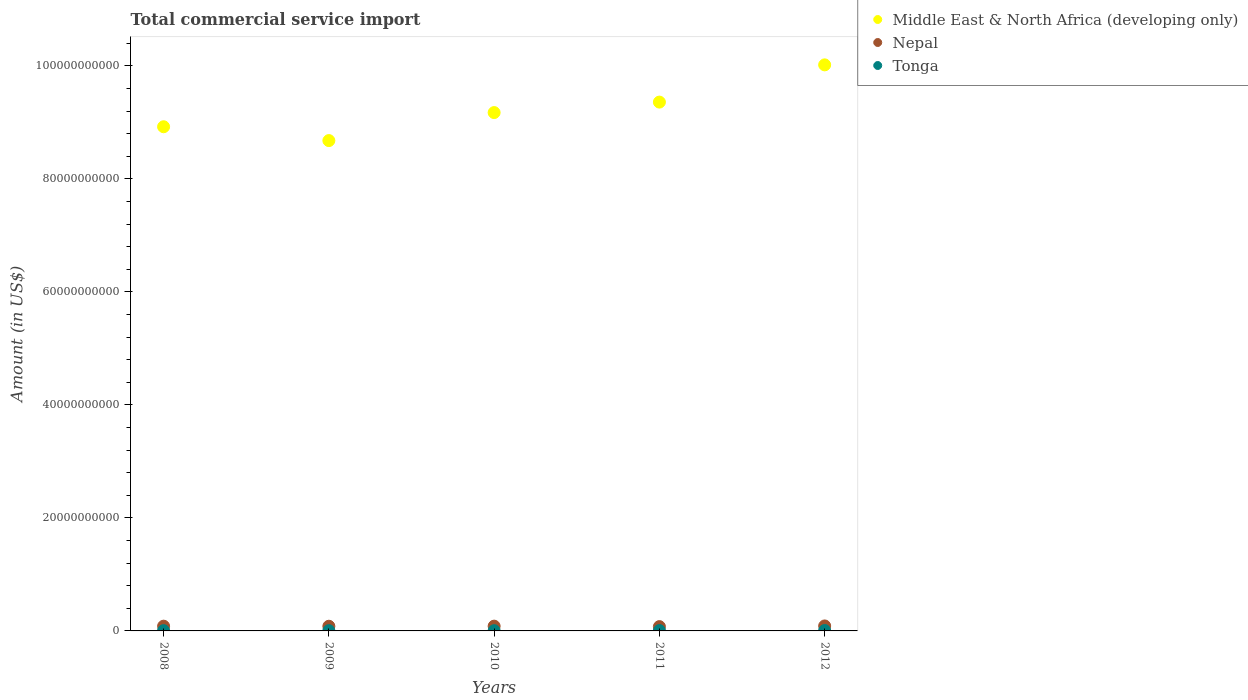How many different coloured dotlines are there?
Offer a very short reply. 3. What is the total commercial service import in Middle East & North Africa (developing only) in 2012?
Your answer should be compact. 1.00e+11. Across all years, what is the maximum total commercial service import in Middle East & North Africa (developing only)?
Ensure brevity in your answer.  1.00e+11. Across all years, what is the minimum total commercial service import in Middle East & North Africa (developing only)?
Offer a very short reply. 8.68e+1. In which year was the total commercial service import in Nepal minimum?
Make the answer very short. 2011. What is the total total commercial service import in Tonga in the graph?
Your answer should be very brief. 2.72e+08. What is the difference between the total commercial service import in Middle East & North Africa (developing only) in 2008 and that in 2009?
Offer a terse response. 2.45e+09. What is the difference between the total commercial service import in Tonga in 2012 and the total commercial service import in Nepal in 2010?
Ensure brevity in your answer.  -7.72e+08. What is the average total commercial service import in Middle East & North Africa (developing only) per year?
Provide a short and direct response. 9.23e+1. In the year 2008, what is the difference between the total commercial service import in Middle East & North Africa (developing only) and total commercial service import in Tonga?
Offer a terse response. 8.92e+1. In how many years, is the total commercial service import in Tonga greater than 88000000000 US$?
Ensure brevity in your answer.  0. What is the ratio of the total commercial service import in Tonga in 2009 to that in 2011?
Provide a succinct answer. 0.7. Is the total commercial service import in Nepal in 2008 less than that in 2009?
Offer a very short reply. No. Is the difference between the total commercial service import in Middle East & North Africa (developing only) in 2008 and 2011 greater than the difference between the total commercial service import in Tonga in 2008 and 2011?
Ensure brevity in your answer.  No. What is the difference between the highest and the second highest total commercial service import in Middle East & North Africa (developing only)?
Make the answer very short. 6.59e+09. What is the difference between the highest and the lowest total commercial service import in Middle East & North Africa (developing only)?
Your answer should be compact. 1.34e+1. In how many years, is the total commercial service import in Middle East & North Africa (developing only) greater than the average total commercial service import in Middle East & North Africa (developing only) taken over all years?
Offer a terse response. 2. Is the sum of the total commercial service import in Nepal in 2008 and 2009 greater than the maximum total commercial service import in Tonga across all years?
Your response must be concise. Yes. Does the total commercial service import in Middle East & North Africa (developing only) monotonically increase over the years?
Provide a succinct answer. No. Is the total commercial service import in Tonga strictly greater than the total commercial service import in Middle East & North Africa (developing only) over the years?
Your answer should be compact. No. Is the total commercial service import in Nepal strictly less than the total commercial service import in Tonga over the years?
Offer a terse response. No. How many dotlines are there?
Your answer should be very brief. 3. What is the difference between two consecutive major ticks on the Y-axis?
Offer a terse response. 2.00e+1. Does the graph contain any zero values?
Your answer should be compact. No. How many legend labels are there?
Offer a very short reply. 3. What is the title of the graph?
Provide a succinct answer. Total commercial service import. What is the label or title of the Y-axis?
Ensure brevity in your answer.  Amount (in US$). What is the Amount (in US$) in Middle East & North Africa (developing only) in 2008?
Your answer should be compact. 8.92e+1. What is the Amount (in US$) of Nepal in 2008?
Ensure brevity in your answer.  8.40e+08. What is the Amount (in US$) in Tonga in 2008?
Your answer should be very brief. 4.82e+07. What is the Amount (in US$) in Middle East & North Africa (developing only) in 2009?
Your answer should be very brief. 8.68e+1. What is the Amount (in US$) of Nepal in 2009?
Ensure brevity in your answer.  8.28e+08. What is the Amount (in US$) in Tonga in 2009?
Your answer should be very brief. 4.43e+07. What is the Amount (in US$) in Middle East & North Africa (developing only) in 2010?
Provide a short and direct response. 9.17e+1. What is the Amount (in US$) in Nepal in 2010?
Offer a very short reply. 8.45e+08. What is the Amount (in US$) of Tonga in 2010?
Provide a succinct answer. 4.24e+07. What is the Amount (in US$) of Middle East & North Africa (developing only) in 2011?
Make the answer very short. 9.36e+1. What is the Amount (in US$) in Nepal in 2011?
Ensure brevity in your answer.  7.61e+08. What is the Amount (in US$) in Tonga in 2011?
Ensure brevity in your answer.  6.34e+07. What is the Amount (in US$) of Middle East & North Africa (developing only) in 2012?
Give a very brief answer. 1.00e+11. What is the Amount (in US$) of Nepal in 2012?
Ensure brevity in your answer.  8.82e+08. What is the Amount (in US$) of Tonga in 2012?
Provide a short and direct response. 7.36e+07. Across all years, what is the maximum Amount (in US$) of Middle East & North Africa (developing only)?
Your response must be concise. 1.00e+11. Across all years, what is the maximum Amount (in US$) in Nepal?
Make the answer very short. 8.82e+08. Across all years, what is the maximum Amount (in US$) of Tonga?
Offer a very short reply. 7.36e+07. Across all years, what is the minimum Amount (in US$) of Middle East & North Africa (developing only)?
Offer a terse response. 8.68e+1. Across all years, what is the minimum Amount (in US$) in Nepal?
Ensure brevity in your answer.  7.61e+08. Across all years, what is the minimum Amount (in US$) of Tonga?
Your response must be concise. 4.24e+07. What is the total Amount (in US$) of Middle East & North Africa (developing only) in the graph?
Your response must be concise. 4.62e+11. What is the total Amount (in US$) in Nepal in the graph?
Ensure brevity in your answer.  4.16e+09. What is the total Amount (in US$) in Tonga in the graph?
Your response must be concise. 2.72e+08. What is the difference between the Amount (in US$) in Middle East & North Africa (developing only) in 2008 and that in 2009?
Your answer should be very brief. 2.45e+09. What is the difference between the Amount (in US$) of Nepal in 2008 and that in 2009?
Your response must be concise. 1.26e+07. What is the difference between the Amount (in US$) in Tonga in 2008 and that in 2009?
Your response must be concise. 3.97e+06. What is the difference between the Amount (in US$) of Middle East & North Africa (developing only) in 2008 and that in 2010?
Make the answer very short. -2.51e+09. What is the difference between the Amount (in US$) in Nepal in 2008 and that in 2010?
Make the answer very short. -5.02e+06. What is the difference between the Amount (in US$) in Tonga in 2008 and that in 2010?
Offer a very short reply. 5.78e+06. What is the difference between the Amount (in US$) in Middle East & North Africa (developing only) in 2008 and that in 2011?
Keep it short and to the point. -4.36e+09. What is the difference between the Amount (in US$) of Nepal in 2008 and that in 2011?
Ensure brevity in your answer.  7.88e+07. What is the difference between the Amount (in US$) in Tonga in 2008 and that in 2011?
Your response must be concise. -1.52e+07. What is the difference between the Amount (in US$) in Middle East & North Africa (developing only) in 2008 and that in 2012?
Make the answer very short. -1.10e+1. What is the difference between the Amount (in US$) in Nepal in 2008 and that in 2012?
Provide a short and direct response. -4.16e+07. What is the difference between the Amount (in US$) in Tonga in 2008 and that in 2012?
Your response must be concise. -2.54e+07. What is the difference between the Amount (in US$) in Middle East & North Africa (developing only) in 2009 and that in 2010?
Give a very brief answer. -4.96e+09. What is the difference between the Amount (in US$) in Nepal in 2009 and that in 2010?
Provide a succinct answer. -1.76e+07. What is the difference between the Amount (in US$) in Tonga in 2009 and that in 2010?
Keep it short and to the point. 1.81e+06. What is the difference between the Amount (in US$) in Middle East & North Africa (developing only) in 2009 and that in 2011?
Your answer should be very brief. -6.81e+09. What is the difference between the Amount (in US$) in Nepal in 2009 and that in 2011?
Keep it short and to the point. 6.61e+07. What is the difference between the Amount (in US$) of Tonga in 2009 and that in 2011?
Provide a succinct answer. -1.92e+07. What is the difference between the Amount (in US$) of Middle East & North Africa (developing only) in 2009 and that in 2012?
Provide a short and direct response. -1.34e+1. What is the difference between the Amount (in US$) in Nepal in 2009 and that in 2012?
Make the answer very short. -5.43e+07. What is the difference between the Amount (in US$) of Tonga in 2009 and that in 2012?
Provide a short and direct response. -2.93e+07. What is the difference between the Amount (in US$) in Middle East & North Africa (developing only) in 2010 and that in 2011?
Provide a succinct answer. -1.85e+09. What is the difference between the Amount (in US$) in Nepal in 2010 and that in 2011?
Keep it short and to the point. 8.38e+07. What is the difference between the Amount (in US$) of Tonga in 2010 and that in 2011?
Provide a succinct answer. -2.10e+07. What is the difference between the Amount (in US$) in Middle East & North Africa (developing only) in 2010 and that in 2012?
Offer a terse response. -8.44e+09. What is the difference between the Amount (in US$) in Nepal in 2010 and that in 2012?
Provide a succinct answer. -3.66e+07. What is the difference between the Amount (in US$) of Tonga in 2010 and that in 2012?
Provide a succinct answer. -3.11e+07. What is the difference between the Amount (in US$) of Middle East & North Africa (developing only) in 2011 and that in 2012?
Make the answer very short. -6.59e+09. What is the difference between the Amount (in US$) in Nepal in 2011 and that in 2012?
Provide a short and direct response. -1.20e+08. What is the difference between the Amount (in US$) in Tonga in 2011 and that in 2012?
Make the answer very short. -1.02e+07. What is the difference between the Amount (in US$) of Middle East & North Africa (developing only) in 2008 and the Amount (in US$) of Nepal in 2009?
Offer a terse response. 8.84e+1. What is the difference between the Amount (in US$) of Middle East & North Africa (developing only) in 2008 and the Amount (in US$) of Tonga in 2009?
Offer a very short reply. 8.92e+1. What is the difference between the Amount (in US$) of Nepal in 2008 and the Amount (in US$) of Tonga in 2009?
Your answer should be compact. 7.96e+08. What is the difference between the Amount (in US$) of Middle East & North Africa (developing only) in 2008 and the Amount (in US$) of Nepal in 2010?
Keep it short and to the point. 8.84e+1. What is the difference between the Amount (in US$) of Middle East & North Africa (developing only) in 2008 and the Amount (in US$) of Tonga in 2010?
Ensure brevity in your answer.  8.92e+1. What is the difference between the Amount (in US$) of Nepal in 2008 and the Amount (in US$) of Tonga in 2010?
Your answer should be very brief. 7.98e+08. What is the difference between the Amount (in US$) of Middle East & North Africa (developing only) in 2008 and the Amount (in US$) of Nepal in 2011?
Give a very brief answer. 8.85e+1. What is the difference between the Amount (in US$) of Middle East & North Africa (developing only) in 2008 and the Amount (in US$) of Tonga in 2011?
Offer a terse response. 8.92e+1. What is the difference between the Amount (in US$) in Nepal in 2008 and the Amount (in US$) in Tonga in 2011?
Make the answer very short. 7.77e+08. What is the difference between the Amount (in US$) in Middle East & North Africa (developing only) in 2008 and the Amount (in US$) in Nepal in 2012?
Give a very brief answer. 8.83e+1. What is the difference between the Amount (in US$) in Middle East & North Africa (developing only) in 2008 and the Amount (in US$) in Tonga in 2012?
Provide a succinct answer. 8.92e+1. What is the difference between the Amount (in US$) in Nepal in 2008 and the Amount (in US$) in Tonga in 2012?
Offer a terse response. 7.67e+08. What is the difference between the Amount (in US$) in Middle East & North Africa (developing only) in 2009 and the Amount (in US$) in Nepal in 2010?
Your answer should be very brief. 8.59e+1. What is the difference between the Amount (in US$) in Middle East & North Africa (developing only) in 2009 and the Amount (in US$) in Tonga in 2010?
Your answer should be compact. 8.67e+1. What is the difference between the Amount (in US$) of Nepal in 2009 and the Amount (in US$) of Tonga in 2010?
Make the answer very short. 7.85e+08. What is the difference between the Amount (in US$) in Middle East & North Africa (developing only) in 2009 and the Amount (in US$) in Nepal in 2011?
Keep it short and to the point. 8.60e+1. What is the difference between the Amount (in US$) of Middle East & North Africa (developing only) in 2009 and the Amount (in US$) of Tonga in 2011?
Provide a short and direct response. 8.67e+1. What is the difference between the Amount (in US$) of Nepal in 2009 and the Amount (in US$) of Tonga in 2011?
Keep it short and to the point. 7.64e+08. What is the difference between the Amount (in US$) of Middle East & North Africa (developing only) in 2009 and the Amount (in US$) of Nepal in 2012?
Your answer should be very brief. 8.59e+1. What is the difference between the Amount (in US$) of Middle East & North Africa (developing only) in 2009 and the Amount (in US$) of Tonga in 2012?
Offer a terse response. 8.67e+1. What is the difference between the Amount (in US$) in Nepal in 2009 and the Amount (in US$) in Tonga in 2012?
Provide a succinct answer. 7.54e+08. What is the difference between the Amount (in US$) in Middle East & North Africa (developing only) in 2010 and the Amount (in US$) in Nepal in 2011?
Offer a terse response. 9.10e+1. What is the difference between the Amount (in US$) of Middle East & North Africa (developing only) in 2010 and the Amount (in US$) of Tonga in 2011?
Ensure brevity in your answer.  9.17e+1. What is the difference between the Amount (in US$) of Nepal in 2010 and the Amount (in US$) of Tonga in 2011?
Offer a very short reply. 7.82e+08. What is the difference between the Amount (in US$) in Middle East & North Africa (developing only) in 2010 and the Amount (in US$) in Nepal in 2012?
Provide a succinct answer. 9.09e+1. What is the difference between the Amount (in US$) of Middle East & North Africa (developing only) in 2010 and the Amount (in US$) of Tonga in 2012?
Your answer should be compact. 9.17e+1. What is the difference between the Amount (in US$) of Nepal in 2010 and the Amount (in US$) of Tonga in 2012?
Offer a terse response. 7.72e+08. What is the difference between the Amount (in US$) in Middle East & North Africa (developing only) in 2011 and the Amount (in US$) in Nepal in 2012?
Provide a short and direct response. 9.27e+1. What is the difference between the Amount (in US$) of Middle East & North Africa (developing only) in 2011 and the Amount (in US$) of Tonga in 2012?
Keep it short and to the point. 9.35e+1. What is the difference between the Amount (in US$) of Nepal in 2011 and the Amount (in US$) of Tonga in 2012?
Provide a short and direct response. 6.88e+08. What is the average Amount (in US$) of Middle East & North Africa (developing only) per year?
Make the answer very short. 9.23e+1. What is the average Amount (in US$) in Nepal per year?
Make the answer very short. 8.31e+08. What is the average Amount (in US$) of Tonga per year?
Your response must be concise. 5.44e+07. In the year 2008, what is the difference between the Amount (in US$) in Middle East & North Africa (developing only) and Amount (in US$) in Nepal?
Ensure brevity in your answer.  8.84e+1. In the year 2008, what is the difference between the Amount (in US$) in Middle East & North Africa (developing only) and Amount (in US$) in Tonga?
Offer a terse response. 8.92e+1. In the year 2008, what is the difference between the Amount (in US$) in Nepal and Amount (in US$) in Tonga?
Give a very brief answer. 7.92e+08. In the year 2009, what is the difference between the Amount (in US$) in Middle East & North Africa (developing only) and Amount (in US$) in Nepal?
Provide a succinct answer. 8.60e+1. In the year 2009, what is the difference between the Amount (in US$) in Middle East & North Africa (developing only) and Amount (in US$) in Tonga?
Make the answer very short. 8.67e+1. In the year 2009, what is the difference between the Amount (in US$) of Nepal and Amount (in US$) of Tonga?
Keep it short and to the point. 7.83e+08. In the year 2010, what is the difference between the Amount (in US$) of Middle East & North Africa (developing only) and Amount (in US$) of Nepal?
Keep it short and to the point. 9.09e+1. In the year 2010, what is the difference between the Amount (in US$) in Middle East & North Africa (developing only) and Amount (in US$) in Tonga?
Provide a succinct answer. 9.17e+1. In the year 2010, what is the difference between the Amount (in US$) in Nepal and Amount (in US$) in Tonga?
Keep it short and to the point. 8.03e+08. In the year 2011, what is the difference between the Amount (in US$) of Middle East & North Africa (developing only) and Amount (in US$) of Nepal?
Provide a short and direct response. 9.28e+1. In the year 2011, what is the difference between the Amount (in US$) of Middle East & North Africa (developing only) and Amount (in US$) of Tonga?
Offer a terse response. 9.35e+1. In the year 2011, what is the difference between the Amount (in US$) in Nepal and Amount (in US$) in Tonga?
Offer a terse response. 6.98e+08. In the year 2012, what is the difference between the Amount (in US$) of Middle East & North Africa (developing only) and Amount (in US$) of Nepal?
Ensure brevity in your answer.  9.93e+1. In the year 2012, what is the difference between the Amount (in US$) in Middle East & North Africa (developing only) and Amount (in US$) in Tonga?
Your answer should be compact. 1.00e+11. In the year 2012, what is the difference between the Amount (in US$) of Nepal and Amount (in US$) of Tonga?
Keep it short and to the point. 8.08e+08. What is the ratio of the Amount (in US$) of Middle East & North Africa (developing only) in 2008 to that in 2009?
Keep it short and to the point. 1.03. What is the ratio of the Amount (in US$) in Nepal in 2008 to that in 2009?
Give a very brief answer. 1.02. What is the ratio of the Amount (in US$) of Tonga in 2008 to that in 2009?
Provide a short and direct response. 1.09. What is the ratio of the Amount (in US$) of Middle East & North Africa (developing only) in 2008 to that in 2010?
Give a very brief answer. 0.97. What is the ratio of the Amount (in US$) of Tonga in 2008 to that in 2010?
Your response must be concise. 1.14. What is the ratio of the Amount (in US$) in Middle East & North Africa (developing only) in 2008 to that in 2011?
Ensure brevity in your answer.  0.95. What is the ratio of the Amount (in US$) of Nepal in 2008 to that in 2011?
Keep it short and to the point. 1.1. What is the ratio of the Amount (in US$) of Tonga in 2008 to that in 2011?
Your answer should be compact. 0.76. What is the ratio of the Amount (in US$) in Middle East & North Africa (developing only) in 2008 to that in 2012?
Offer a terse response. 0.89. What is the ratio of the Amount (in US$) of Nepal in 2008 to that in 2012?
Provide a succinct answer. 0.95. What is the ratio of the Amount (in US$) of Tonga in 2008 to that in 2012?
Your answer should be very brief. 0.66. What is the ratio of the Amount (in US$) of Middle East & North Africa (developing only) in 2009 to that in 2010?
Offer a terse response. 0.95. What is the ratio of the Amount (in US$) of Nepal in 2009 to that in 2010?
Keep it short and to the point. 0.98. What is the ratio of the Amount (in US$) in Tonga in 2009 to that in 2010?
Provide a succinct answer. 1.04. What is the ratio of the Amount (in US$) in Middle East & North Africa (developing only) in 2009 to that in 2011?
Your answer should be very brief. 0.93. What is the ratio of the Amount (in US$) of Nepal in 2009 to that in 2011?
Keep it short and to the point. 1.09. What is the ratio of the Amount (in US$) in Tonga in 2009 to that in 2011?
Your response must be concise. 0.7. What is the ratio of the Amount (in US$) of Middle East & North Africa (developing only) in 2009 to that in 2012?
Your answer should be very brief. 0.87. What is the ratio of the Amount (in US$) in Nepal in 2009 to that in 2012?
Your answer should be compact. 0.94. What is the ratio of the Amount (in US$) in Tonga in 2009 to that in 2012?
Offer a very short reply. 0.6. What is the ratio of the Amount (in US$) in Middle East & North Africa (developing only) in 2010 to that in 2011?
Ensure brevity in your answer.  0.98. What is the ratio of the Amount (in US$) in Nepal in 2010 to that in 2011?
Ensure brevity in your answer.  1.11. What is the ratio of the Amount (in US$) in Tonga in 2010 to that in 2011?
Make the answer very short. 0.67. What is the ratio of the Amount (in US$) of Middle East & North Africa (developing only) in 2010 to that in 2012?
Your answer should be very brief. 0.92. What is the ratio of the Amount (in US$) in Nepal in 2010 to that in 2012?
Your response must be concise. 0.96. What is the ratio of the Amount (in US$) of Tonga in 2010 to that in 2012?
Offer a very short reply. 0.58. What is the ratio of the Amount (in US$) in Middle East & North Africa (developing only) in 2011 to that in 2012?
Give a very brief answer. 0.93. What is the ratio of the Amount (in US$) of Nepal in 2011 to that in 2012?
Make the answer very short. 0.86. What is the ratio of the Amount (in US$) of Tonga in 2011 to that in 2012?
Give a very brief answer. 0.86. What is the difference between the highest and the second highest Amount (in US$) in Middle East & North Africa (developing only)?
Offer a terse response. 6.59e+09. What is the difference between the highest and the second highest Amount (in US$) of Nepal?
Offer a very short reply. 3.66e+07. What is the difference between the highest and the second highest Amount (in US$) of Tonga?
Offer a very short reply. 1.02e+07. What is the difference between the highest and the lowest Amount (in US$) of Middle East & North Africa (developing only)?
Your answer should be very brief. 1.34e+1. What is the difference between the highest and the lowest Amount (in US$) in Nepal?
Your answer should be compact. 1.20e+08. What is the difference between the highest and the lowest Amount (in US$) of Tonga?
Your answer should be very brief. 3.11e+07. 